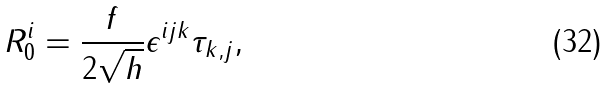Convert formula to latex. <formula><loc_0><loc_0><loc_500><loc_500>R _ { 0 } ^ { i } = \frac { f } { 2 \sqrt { h } } \epsilon ^ { i j k } \tau _ { k , j } ,</formula> 